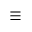Convert formula to latex. <formula><loc_0><loc_0><loc_500><loc_500>\equiv</formula> 